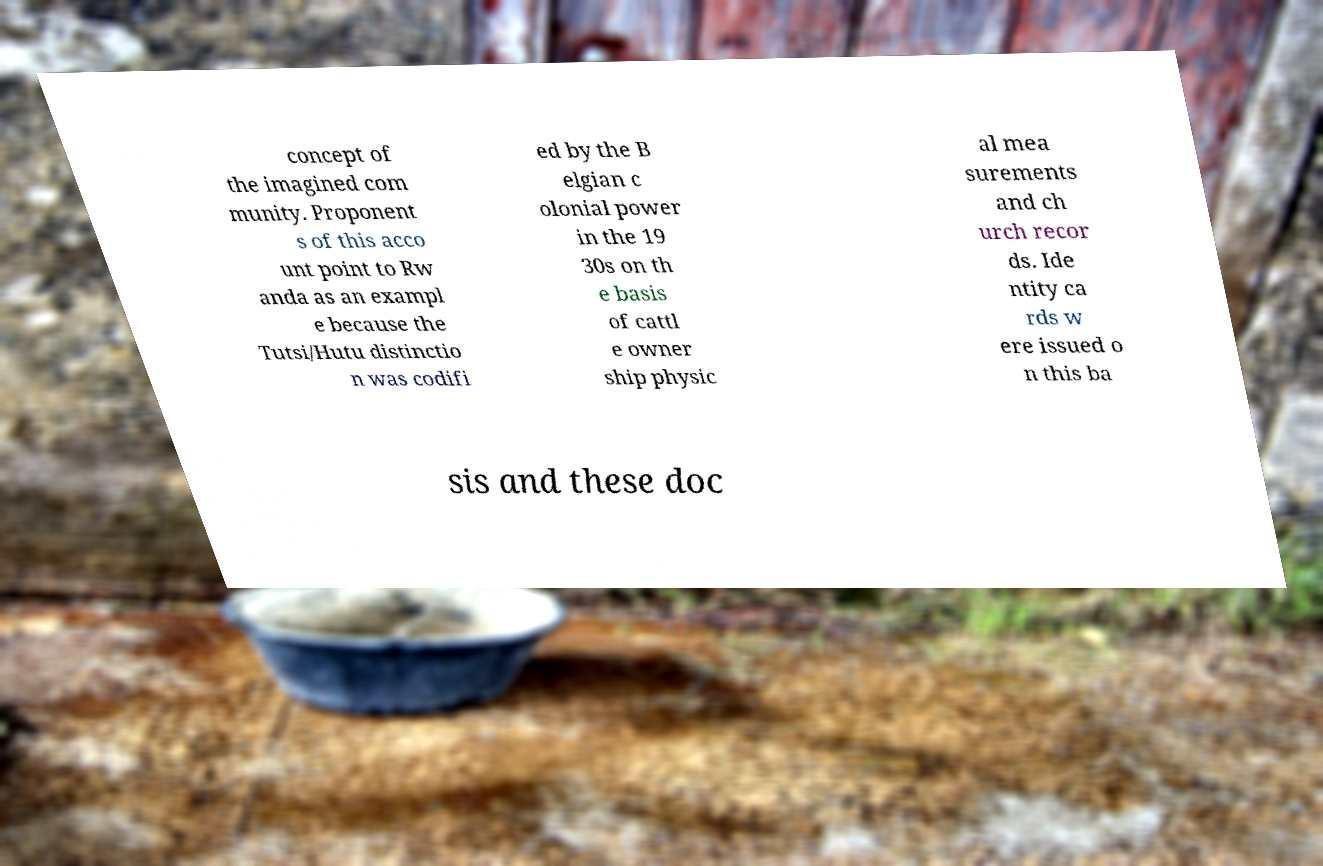For documentation purposes, I need the text within this image transcribed. Could you provide that? concept of the imagined com munity. Proponent s of this acco unt point to Rw anda as an exampl e because the Tutsi/Hutu distinctio n was codifi ed by the B elgian c olonial power in the 19 30s on th e basis of cattl e owner ship physic al mea surements and ch urch recor ds. Ide ntity ca rds w ere issued o n this ba sis and these doc 